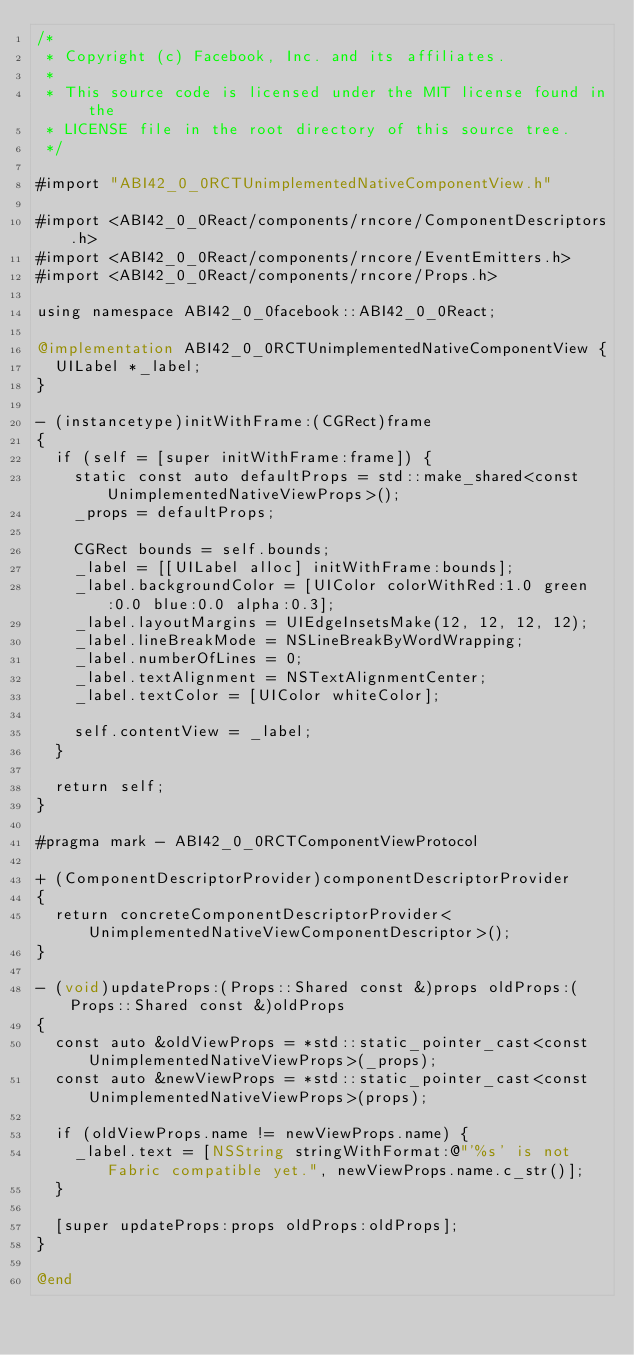<code> <loc_0><loc_0><loc_500><loc_500><_ObjectiveC_>/*
 * Copyright (c) Facebook, Inc. and its affiliates.
 *
 * This source code is licensed under the MIT license found in the
 * LICENSE file in the root directory of this source tree.
 */

#import "ABI42_0_0RCTUnimplementedNativeComponentView.h"

#import <ABI42_0_0React/components/rncore/ComponentDescriptors.h>
#import <ABI42_0_0React/components/rncore/EventEmitters.h>
#import <ABI42_0_0React/components/rncore/Props.h>

using namespace ABI42_0_0facebook::ABI42_0_0React;

@implementation ABI42_0_0RCTUnimplementedNativeComponentView {
  UILabel *_label;
}

- (instancetype)initWithFrame:(CGRect)frame
{
  if (self = [super initWithFrame:frame]) {
    static const auto defaultProps = std::make_shared<const UnimplementedNativeViewProps>();
    _props = defaultProps;

    CGRect bounds = self.bounds;
    _label = [[UILabel alloc] initWithFrame:bounds];
    _label.backgroundColor = [UIColor colorWithRed:1.0 green:0.0 blue:0.0 alpha:0.3];
    _label.layoutMargins = UIEdgeInsetsMake(12, 12, 12, 12);
    _label.lineBreakMode = NSLineBreakByWordWrapping;
    _label.numberOfLines = 0;
    _label.textAlignment = NSTextAlignmentCenter;
    _label.textColor = [UIColor whiteColor];

    self.contentView = _label;
  }

  return self;
}

#pragma mark - ABI42_0_0RCTComponentViewProtocol

+ (ComponentDescriptorProvider)componentDescriptorProvider
{
  return concreteComponentDescriptorProvider<UnimplementedNativeViewComponentDescriptor>();
}

- (void)updateProps:(Props::Shared const &)props oldProps:(Props::Shared const &)oldProps
{
  const auto &oldViewProps = *std::static_pointer_cast<const UnimplementedNativeViewProps>(_props);
  const auto &newViewProps = *std::static_pointer_cast<const UnimplementedNativeViewProps>(props);

  if (oldViewProps.name != newViewProps.name) {
    _label.text = [NSString stringWithFormat:@"'%s' is not Fabric compatible yet.", newViewProps.name.c_str()];
  }

  [super updateProps:props oldProps:oldProps];
}

@end
</code> 